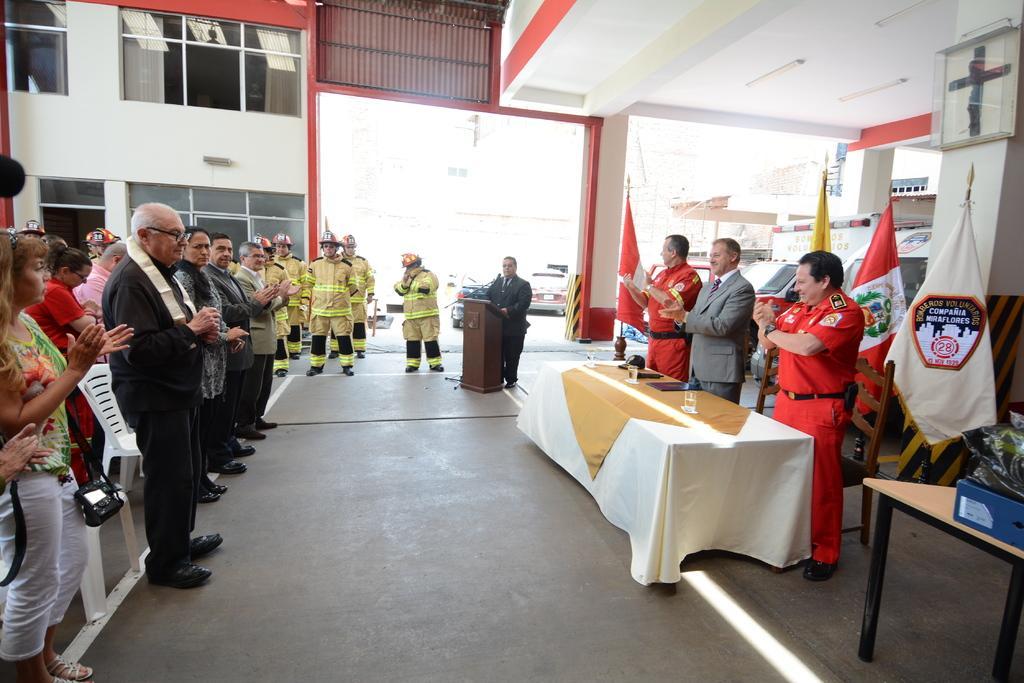Describe this image in one or two sentences. In this image, There is a floor which is of gray color, In the right side there is a table which is covered by a white color cloth and on that table there are some glasses and there are some people standing, In the background there is a white color wall and in the top there is a white color roof. 